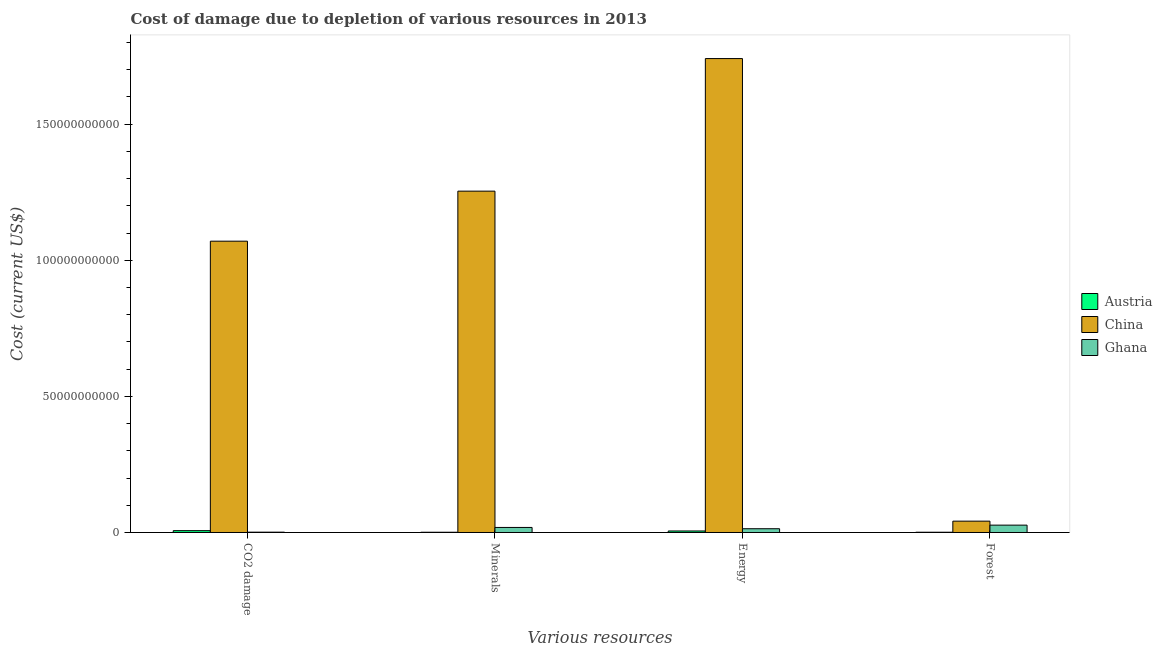How many different coloured bars are there?
Make the answer very short. 3. How many groups of bars are there?
Provide a succinct answer. 4. What is the label of the 4th group of bars from the left?
Offer a terse response. Forest. What is the cost of damage due to depletion of minerals in China?
Offer a terse response. 1.25e+11. Across all countries, what is the maximum cost of damage due to depletion of coal?
Your response must be concise. 1.07e+11. Across all countries, what is the minimum cost of damage due to depletion of minerals?
Your answer should be very brief. 8.96e+07. In which country was the cost of damage due to depletion of forests minimum?
Provide a succinct answer. Austria. What is the total cost of damage due to depletion of minerals in the graph?
Make the answer very short. 1.27e+11. What is the difference between the cost of damage due to depletion of coal in China and that in Austria?
Your response must be concise. 1.06e+11. What is the difference between the cost of damage due to depletion of energy in China and the cost of damage due to depletion of coal in Austria?
Provide a short and direct response. 1.73e+11. What is the average cost of damage due to depletion of energy per country?
Your answer should be compact. 5.87e+1. What is the difference between the cost of damage due to depletion of minerals and cost of damage due to depletion of energy in Ghana?
Your response must be concise. 4.70e+08. In how many countries, is the cost of damage due to depletion of forests greater than 130000000000 US$?
Keep it short and to the point. 0. What is the ratio of the cost of damage due to depletion of energy in China to that in Austria?
Your response must be concise. 315.01. Is the cost of damage due to depletion of energy in Ghana less than that in China?
Ensure brevity in your answer.  Yes. What is the difference between the highest and the second highest cost of damage due to depletion of coal?
Make the answer very short. 1.06e+11. What is the difference between the highest and the lowest cost of damage due to depletion of coal?
Offer a very short reply. 1.07e+11. In how many countries, is the cost of damage due to depletion of coal greater than the average cost of damage due to depletion of coal taken over all countries?
Your response must be concise. 1. Is it the case that in every country, the sum of the cost of damage due to depletion of coal and cost of damage due to depletion of forests is greater than the sum of cost of damage due to depletion of energy and cost of damage due to depletion of minerals?
Your answer should be compact. No. What does the 1st bar from the left in Energy represents?
Your answer should be compact. Austria. What does the 3rd bar from the right in CO2 damage represents?
Your answer should be compact. Austria. What is the difference between two consecutive major ticks on the Y-axis?
Keep it short and to the point. 5.00e+1. Are the values on the major ticks of Y-axis written in scientific E-notation?
Ensure brevity in your answer.  No. Does the graph contain any zero values?
Provide a succinct answer. No. Does the graph contain grids?
Keep it short and to the point. No. Where does the legend appear in the graph?
Your answer should be very brief. Center right. What is the title of the graph?
Your response must be concise. Cost of damage due to depletion of various resources in 2013 . What is the label or title of the X-axis?
Offer a very short reply. Various resources. What is the label or title of the Y-axis?
Provide a short and direct response. Cost (current US$). What is the Cost (current US$) of Austria in CO2 damage?
Make the answer very short. 6.74e+08. What is the Cost (current US$) of China in CO2 damage?
Your answer should be compact. 1.07e+11. What is the Cost (current US$) in Ghana in CO2 damage?
Your response must be concise. 1.21e+08. What is the Cost (current US$) of Austria in Minerals?
Your answer should be very brief. 8.96e+07. What is the Cost (current US$) in China in Minerals?
Make the answer very short. 1.25e+11. What is the Cost (current US$) in Ghana in Minerals?
Offer a terse response. 1.85e+09. What is the Cost (current US$) in Austria in Energy?
Your response must be concise. 5.53e+08. What is the Cost (current US$) in China in Energy?
Offer a very short reply. 1.74e+11. What is the Cost (current US$) in Ghana in Energy?
Give a very brief answer. 1.38e+09. What is the Cost (current US$) of Austria in Forest?
Give a very brief answer. 9.76e+07. What is the Cost (current US$) in China in Forest?
Your answer should be compact. 4.16e+09. What is the Cost (current US$) in Ghana in Forest?
Ensure brevity in your answer.  2.70e+09. Across all Various resources, what is the maximum Cost (current US$) of Austria?
Your response must be concise. 6.74e+08. Across all Various resources, what is the maximum Cost (current US$) of China?
Your answer should be very brief. 1.74e+11. Across all Various resources, what is the maximum Cost (current US$) of Ghana?
Provide a short and direct response. 2.70e+09. Across all Various resources, what is the minimum Cost (current US$) in Austria?
Give a very brief answer. 8.96e+07. Across all Various resources, what is the minimum Cost (current US$) in China?
Provide a short and direct response. 4.16e+09. Across all Various resources, what is the minimum Cost (current US$) in Ghana?
Make the answer very short. 1.21e+08. What is the total Cost (current US$) of Austria in the graph?
Provide a short and direct response. 1.41e+09. What is the total Cost (current US$) in China in the graph?
Make the answer very short. 4.11e+11. What is the total Cost (current US$) of Ghana in the graph?
Make the answer very short. 6.06e+09. What is the difference between the Cost (current US$) in Austria in CO2 damage and that in Minerals?
Give a very brief answer. 5.85e+08. What is the difference between the Cost (current US$) in China in CO2 damage and that in Minerals?
Provide a short and direct response. -1.84e+1. What is the difference between the Cost (current US$) in Ghana in CO2 damage and that in Minerals?
Your answer should be compact. -1.73e+09. What is the difference between the Cost (current US$) in Austria in CO2 damage and that in Energy?
Your answer should be very brief. 1.21e+08. What is the difference between the Cost (current US$) in China in CO2 damage and that in Energy?
Your response must be concise. -6.71e+1. What is the difference between the Cost (current US$) of Ghana in CO2 damage and that in Energy?
Offer a terse response. -1.26e+09. What is the difference between the Cost (current US$) of Austria in CO2 damage and that in Forest?
Make the answer very short. 5.77e+08. What is the difference between the Cost (current US$) in China in CO2 damage and that in Forest?
Make the answer very short. 1.03e+11. What is the difference between the Cost (current US$) of Ghana in CO2 damage and that in Forest?
Give a very brief answer. -2.58e+09. What is the difference between the Cost (current US$) in Austria in Minerals and that in Energy?
Make the answer very short. -4.63e+08. What is the difference between the Cost (current US$) in China in Minerals and that in Energy?
Offer a very short reply. -4.87e+1. What is the difference between the Cost (current US$) of Ghana in Minerals and that in Energy?
Ensure brevity in your answer.  4.70e+08. What is the difference between the Cost (current US$) of Austria in Minerals and that in Forest?
Provide a short and direct response. -7.99e+06. What is the difference between the Cost (current US$) of China in Minerals and that in Forest?
Make the answer very short. 1.21e+11. What is the difference between the Cost (current US$) of Ghana in Minerals and that in Forest?
Make the answer very short. -8.49e+08. What is the difference between the Cost (current US$) in Austria in Energy and that in Forest?
Offer a terse response. 4.55e+08. What is the difference between the Cost (current US$) in China in Energy and that in Forest?
Offer a terse response. 1.70e+11. What is the difference between the Cost (current US$) in Ghana in Energy and that in Forest?
Your response must be concise. -1.32e+09. What is the difference between the Cost (current US$) in Austria in CO2 damage and the Cost (current US$) in China in Minerals?
Offer a terse response. -1.25e+11. What is the difference between the Cost (current US$) in Austria in CO2 damage and the Cost (current US$) in Ghana in Minerals?
Offer a terse response. -1.18e+09. What is the difference between the Cost (current US$) in China in CO2 damage and the Cost (current US$) in Ghana in Minerals?
Keep it short and to the point. 1.05e+11. What is the difference between the Cost (current US$) of Austria in CO2 damage and the Cost (current US$) of China in Energy?
Ensure brevity in your answer.  -1.73e+11. What is the difference between the Cost (current US$) of Austria in CO2 damage and the Cost (current US$) of Ghana in Energy?
Give a very brief answer. -7.09e+08. What is the difference between the Cost (current US$) of China in CO2 damage and the Cost (current US$) of Ghana in Energy?
Make the answer very short. 1.06e+11. What is the difference between the Cost (current US$) in Austria in CO2 damage and the Cost (current US$) in China in Forest?
Your answer should be very brief. -3.49e+09. What is the difference between the Cost (current US$) of Austria in CO2 damage and the Cost (current US$) of Ghana in Forest?
Provide a short and direct response. -2.03e+09. What is the difference between the Cost (current US$) in China in CO2 damage and the Cost (current US$) in Ghana in Forest?
Offer a terse response. 1.04e+11. What is the difference between the Cost (current US$) in Austria in Minerals and the Cost (current US$) in China in Energy?
Your answer should be compact. -1.74e+11. What is the difference between the Cost (current US$) of Austria in Minerals and the Cost (current US$) of Ghana in Energy?
Make the answer very short. -1.29e+09. What is the difference between the Cost (current US$) in China in Minerals and the Cost (current US$) in Ghana in Energy?
Your answer should be compact. 1.24e+11. What is the difference between the Cost (current US$) in Austria in Minerals and the Cost (current US$) in China in Forest?
Offer a terse response. -4.07e+09. What is the difference between the Cost (current US$) in Austria in Minerals and the Cost (current US$) in Ghana in Forest?
Your response must be concise. -2.61e+09. What is the difference between the Cost (current US$) of China in Minerals and the Cost (current US$) of Ghana in Forest?
Offer a terse response. 1.23e+11. What is the difference between the Cost (current US$) of Austria in Energy and the Cost (current US$) of China in Forest?
Give a very brief answer. -3.61e+09. What is the difference between the Cost (current US$) in Austria in Energy and the Cost (current US$) in Ghana in Forest?
Offer a terse response. -2.15e+09. What is the difference between the Cost (current US$) of China in Energy and the Cost (current US$) of Ghana in Forest?
Provide a short and direct response. 1.71e+11. What is the average Cost (current US$) of Austria per Various resources?
Make the answer very short. 3.53e+08. What is the average Cost (current US$) in China per Various resources?
Your answer should be compact. 1.03e+11. What is the average Cost (current US$) of Ghana per Various resources?
Your answer should be very brief. 1.51e+09. What is the difference between the Cost (current US$) of Austria and Cost (current US$) of China in CO2 damage?
Your answer should be very brief. -1.06e+11. What is the difference between the Cost (current US$) in Austria and Cost (current US$) in Ghana in CO2 damage?
Provide a short and direct response. 5.53e+08. What is the difference between the Cost (current US$) in China and Cost (current US$) in Ghana in CO2 damage?
Provide a succinct answer. 1.07e+11. What is the difference between the Cost (current US$) in Austria and Cost (current US$) in China in Minerals?
Provide a succinct answer. -1.25e+11. What is the difference between the Cost (current US$) of Austria and Cost (current US$) of Ghana in Minerals?
Make the answer very short. -1.76e+09. What is the difference between the Cost (current US$) in China and Cost (current US$) in Ghana in Minerals?
Give a very brief answer. 1.24e+11. What is the difference between the Cost (current US$) in Austria and Cost (current US$) in China in Energy?
Your answer should be compact. -1.74e+11. What is the difference between the Cost (current US$) in Austria and Cost (current US$) in Ghana in Energy?
Provide a short and direct response. -8.30e+08. What is the difference between the Cost (current US$) in China and Cost (current US$) in Ghana in Energy?
Give a very brief answer. 1.73e+11. What is the difference between the Cost (current US$) of Austria and Cost (current US$) of China in Forest?
Your answer should be very brief. -4.07e+09. What is the difference between the Cost (current US$) of Austria and Cost (current US$) of Ghana in Forest?
Your response must be concise. -2.60e+09. What is the difference between the Cost (current US$) in China and Cost (current US$) in Ghana in Forest?
Your response must be concise. 1.46e+09. What is the ratio of the Cost (current US$) in Austria in CO2 damage to that in Minerals?
Give a very brief answer. 7.53. What is the ratio of the Cost (current US$) in China in CO2 damage to that in Minerals?
Make the answer very short. 0.85. What is the ratio of the Cost (current US$) of Ghana in CO2 damage to that in Minerals?
Your answer should be compact. 0.07. What is the ratio of the Cost (current US$) in Austria in CO2 damage to that in Energy?
Keep it short and to the point. 1.22. What is the ratio of the Cost (current US$) of China in CO2 damage to that in Energy?
Your answer should be compact. 0.61. What is the ratio of the Cost (current US$) in Ghana in CO2 damage to that in Energy?
Ensure brevity in your answer.  0.09. What is the ratio of the Cost (current US$) in Austria in CO2 damage to that in Forest?
Provide a short and direct response. 6.91. What is the ratio of the Cost (current US$) in China in CO2 damage to that in Forest?
Make the answer very short. 25.7. What is the ratio of the Cost (current US$) in Ghana in CO2 damage to that in Forest?
Provide a succinct answer. 0.04. What is the ratio of the Cost (current US$) of Austria in Minerals to that in Energy?
Your response must be concise. 0.16. What is the ratio of the Cost (current US$) of China in Minerals to that in Energy?
Provide a succinct answer. 0.72. What is the ratio of the Cost (current US$) of Ghana in Minerals to that in Energy?
Offer a terse response. 1.34. What is the ratio of the Cost (current US$) of Austria in Minerals to that in Forest?
Give a very brief answer. 0.92. What is the ratio of the Cost (current US$) in China in Minerals to that in Forest?
Provide a succinct answer. 30.12. What is the ratio of the Cost (current US$) of Ghana in Minerals to that in Forest?
Make the answer very short. 0.69. What is the ratio of the Cost (current US$) of Austria in Energy to that in Forest?
Give a very brief answer. 5.66. What is the ratio of the Cost (current US$) in China in Energy to that in Forest?
Your answer should be compact. 41.82. What is the ratio of the Cost (current US$) in Ghana in Energy to that in Forest?
Provide a succinct answer. 0.51. What is the difference between the highest and the second highest Cost (current US$) in Austria?
Make the answer very short. 1.21e+08. What is the difference between the highest and the second highest Cost (current US$) of China?
Offer a very short reply. 4.87e+1. What is the difference between the highest and the second highest Cost (current US$) in Ghana?
Your response must be concise. 8.49e+08. What is the difference between the highest and the lowest Cost (current US$) of Austria?
Give a very brief answer. 5.85e+08. What is the difference between the highest and the lowest Cost (current US$) of China?
Make the answer very short. 1.70e+11. What is the difference between the highest and the lowest Cost (current US$) of Ghana?
Give a very brief answer. 2.58e+09. 